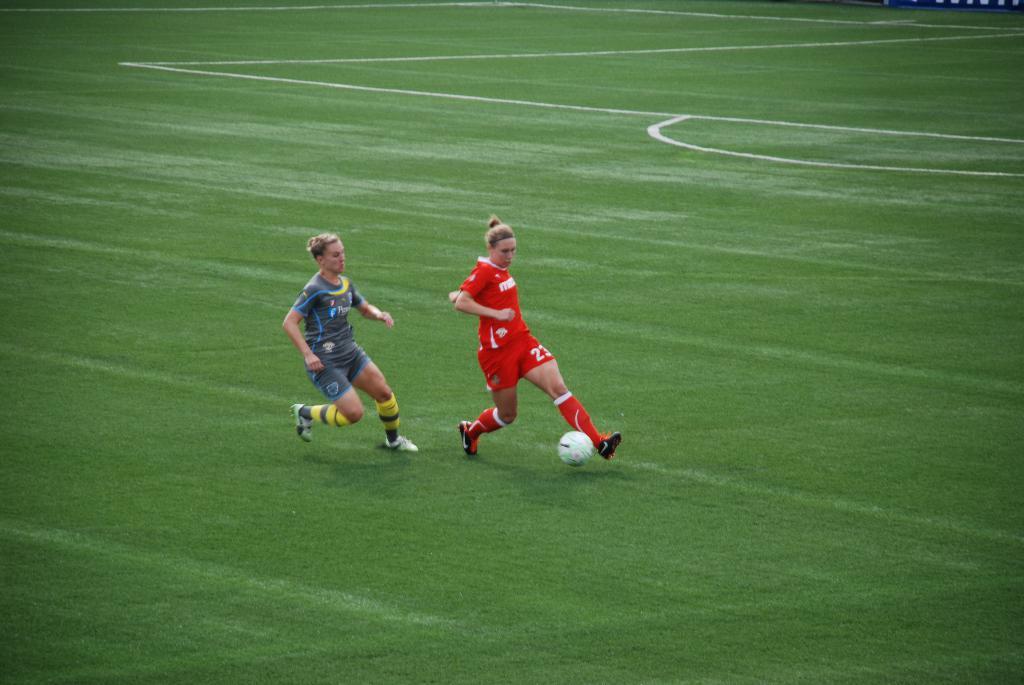What uniform number is the player in red?
Give a very brief answer. 23. 